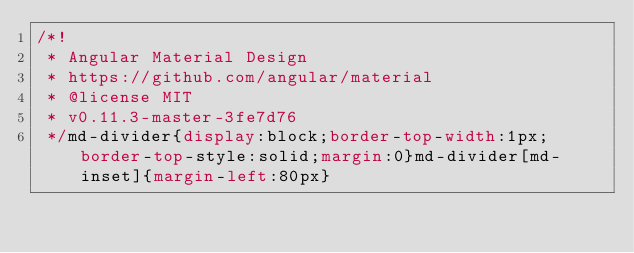Convert code to text. <code><loc_0><loc_0><loc_500><loc_500><_CSS_>/*!
 * Angular Material Design
 * https://github.com/angular/material
 * @license MIT
 * v0.11.3-master-3fe7d76
 */md-divider{display:block;border-top-width:1px;border-top-style:solid;margin:0}md-divider[md-inset]{margin-left:80px}</code> 